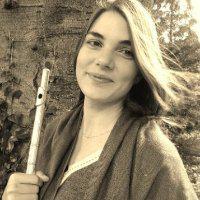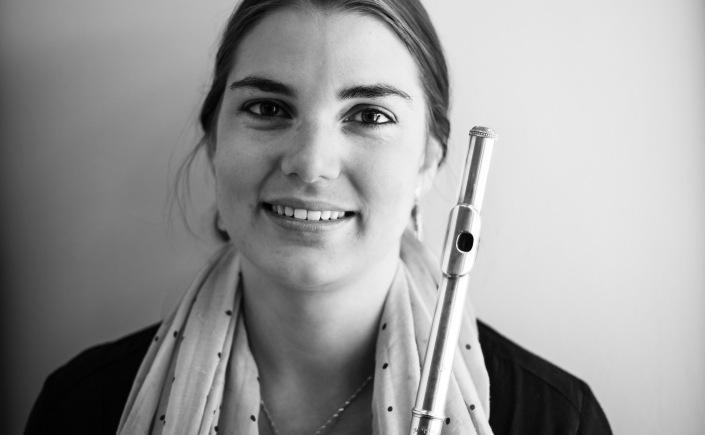The first image is the image on the left, the second image is the image on the right. Considering the images on both sides, is "One image shows a woman with a flute alongside her face on the left, and the other image shows a model with a flute horizontal to her mouth." valid? Answer yes or no. No. The first image is the image on the left, the second image is the image on the right. For the images shown, is this caption "One image shows a woman with a flute touching her mouth." true? Answer yes or no. No. 